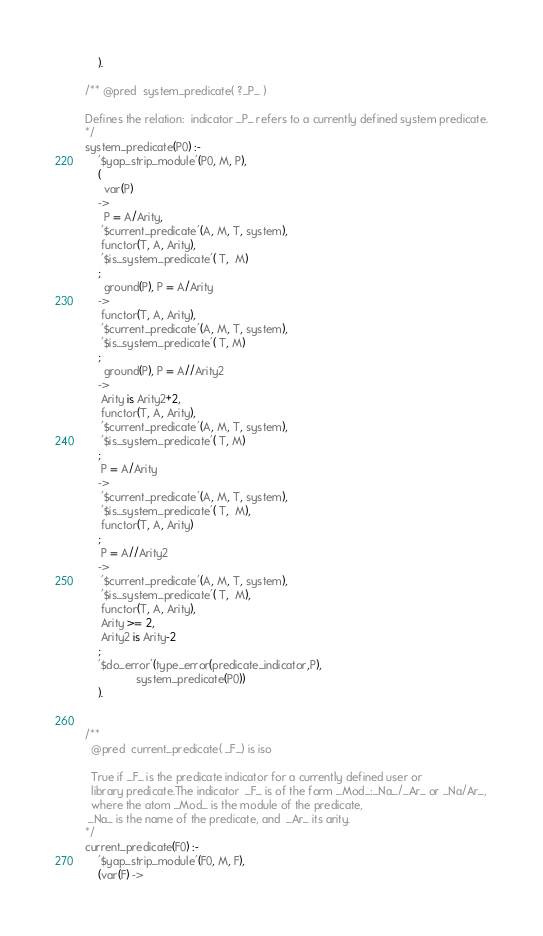<code> <loc_0><loc_0><loc_500><loc_500><_Prolog_>    ).

/** @pred  system_predicate( ?_P_ )

Defines the relation:  indicator _P_ refers to a currently defined system predicate.
*/
system_predicate(P0) :-
	'$yap_strip_module'(P0, M, P),
    (
      var(P)
    ->
      P = A/Arity,
     '$current_predicate'(A, M, T, system),
     functor(T, A, Arity),
     '$is_system_predicate'( T,  M)
    ;
      ground(P), P = A/Arity
    ->
     functor(T, A, Arity),
     '$current_predicate'(A, M, T, system),
     '$is_system_predicate'( T, M)
    ;
      ground(P), P = A//Arity2
    ->
     Arity is Arity2+2,
     functor(T, A, Arity),
     '$current_predicate'(A, M, T, system),
     '$is_system_predicate'( T, M)
    ;
     P = A/Arity
    ->
     '$current_predicate'(A, M, T, system),
     '$is_system_predicate'( T,  M),
     functor(T, A, Arity)
    ;
     P = A//Arity2
    ->
     '$current_predicate'(A, M, T, system),
     '$is_system_predicate'( T,  M),
     functor(T, A, Arity),
     Arity >= 2,
     Arity2 is Arity-2
    ;
    '$do_error'(type_error(predicate_indicator,P),
                system_predicate(P0))
    ).


/**
  @pred  current_predicate( _F_) is iso

  True if _F_ is the predicate indicator for a currently defined user or
  library predicate.The indicator  _F_ is of the form _Mod_:_Na_/_Ar_ or _Na/Ar_,
  where the atom _Mod_ is the module of the predicate,
 _Na_ is the name of the predicate, and  _Ar_ its arity.
*/
current_predicate(F0) :-
	'$yap_strip_module'(F0, M, F),
	(var(F) -></code> 